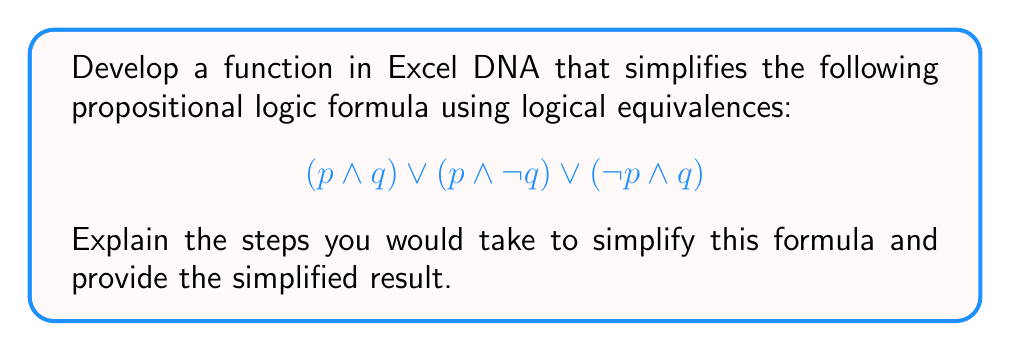Show me your answer to this math problem. To simplify this propositional logic formula using logical equivalences, we can follow these steps:

1. Recognize the structure: We have three terms connected by OR ($\lor$) operators.

2. Apply the distributive law: $(p \land q) \lor (p \land \lnot q)$ can be factored out as $p \land (q \lor \lnot q)$.

3. Simplify using the law of excluded middle: $(q \lor \lnot q)$ is always true, so it can be replaced with $\top$ (true).

4. Apply the identity law: $p \land \top$ simplifies to $p$.

5. Our formula is now: $p \lor (\lnot p \land q)$

6. Apply the absorption law: $p \lor (\lnot p \land q)$ simplifies to $p \lor q$.

In Excel DNA, you could implement this simplification process as follows:

1. Create a custom function that takes the formula as input, represented as a string or using a custom object structure.

2. Implement pattern matching to identify common logical structures and apply the appropriate equivalence rules.

3. Recursively apply these simplification rules until no further simplification is possible.

4. Return the simplified formula as the result.

The final simplified formula is $p \lor q$, which is logically equivalent to the original formula but much simpler.
Answer: $p \lor q$ 